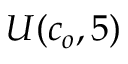<formula> <loc_0><loc_0><loc_500><loc_500>U ( c _ { o } , 5 )</formula> 